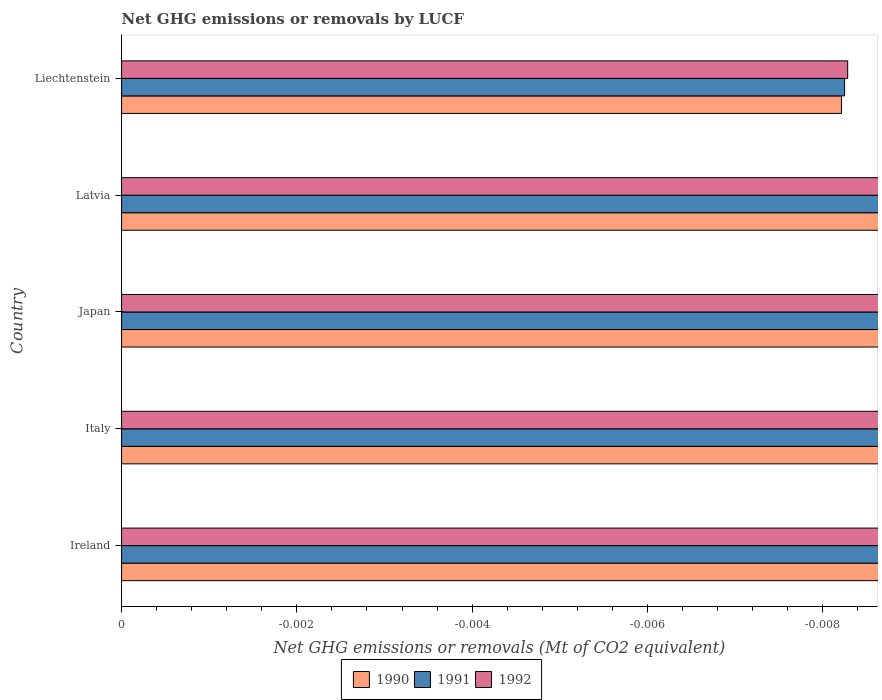Are the number of bars per tick equal to the number of legend labels?
Your response must be concise. No. Are the number of bars on each tick of the Y-axis equal?
Give a very brief answer. Yes. How many bars are there on the 5th tick from the top?
Provide a short and direct response. 0. What is the label of the 2nd group of bars from the top?
Ensure brevity in your answer.  Latvia. What is the net GHG emissions or removals by LUCF in 1990 in Liechtenstein?
Provide a short and direct response. 0. What is the total net GHG emissions or removals by LUCF in 1992 in the graph?
Provide a succinct answer. 0. What is the difference between the net GHG emissions or removals by LUCF in 1991 in Ireland and the net GHG emissions or removals by LUCF in 1990 in Latvia?
Give a very brief answer. 0. What is the average net GHG emissions or removals by LUCF in 1992 per country?
Provide a succinct answer. 0. In how many countries, is the net GHG emissions or removals by LUCF in 1991 greater than -0.0007999999999999999 Mt?
Ensure brevity in your answer.  0. Is it the case that in every country, the sum of the net GHG emissions or removals by LUCF in 1991 and net GHG emissions or removals by LUCF in 1990 is greater than the net GHG emissions or removals by LUCF in 1992?
Your answer should be very brief. No. Are all the bars in the graph horizontal?
Provide a short and direct response. Yes. What is the difference between two consecutive major ticks on the X-axis?
Keep it short and to the point. 0. Are the values on the major ticks of X-axis written in scientific E-notation?
Make the answer very short. No. Does the graph contain grids?
Offer a very short reply. No. Where does the legend appear in the graph?
Your answer should be very brief. Bottom center. How are the legend labels stacked?
Provide a short and direct response. Horizontal. What is the title of the graph?
Give a very brief answer. Net GHG emissions or removals by LUCF. Does "1970" appear as one of the legend labels in the graph?
Ensure brevity in your answer.  No. What is the label or title of the X-axis?
Offer a very short reply. Net GHG emissions or removals (Mt of CO2 equivalent). What is the label or title of the Y-axis?
Make the answer very short. Country. What is the Net GHG emissions or removals (Mt of CO2 equivalent) of 1990 in Ireland?
Keep it short and to the point. 0. What is the Net GHG emissions or removals (Mt of CO2 equivalent) in 1992 in Ireland?
Give a very brief answer. 0. What is the Net GHG emissions or removals (Mt of CO2 equivalent) in 1991 in Italy?
Your response must be concise. 0. What is the Net GHG emissions or removals (Mt of CO2 equivalent) of 1992 in Italy?
Make the answer very short. 0. What is the Net GHG emissions or removals (Mt of CO2 equivalent) of 1991 in Japan?
Provide a succinct answer. 0. What is the Net GHG emissions or removals (Mt of CO2 equivalent) in 1992 in Japan?
Make the answer very short. 0. What is the Net GHG emissions or removals (Mt of CO2 equivalent) of 1992 in Liechtenstein?
Your answer should be compact. 0. What is the total Net GHG emissions or removals (Mt of CO2 equivalent) of 1990 in the graph?
Provide a short and direct response. 0. What is the total Net GHG emissions or removals (Mt of CO2 equivalent) in 1991 in the graph?
Make the answer very short. 0. What is the total Net GHG emissions or removals (Mt of CO2 equivalent) of 1992 in the graph?
Offer a very short reply. 0. What is the average Net GHG emissions or removals (Mt of CO2 equivalent) in 1991 per country?
Offer a very short reply. 0. What is the average Net GHG emissions or removals (Mt of CO2 equivalent) in 1992 per country?
Provide a succinct answer. 0. 